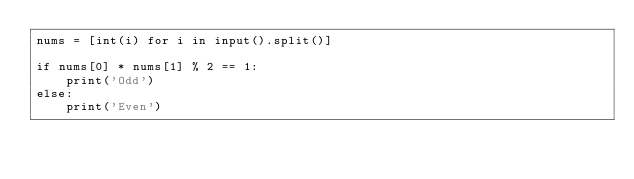<code> <loc_0><loc_0><loc_500><loc_500><_Python_>nums = [int(i) for i in input().split()]

if nums[0] * nums[1] % 2 == 1:
    print('Odd')
else:
    print('Even')</code> 